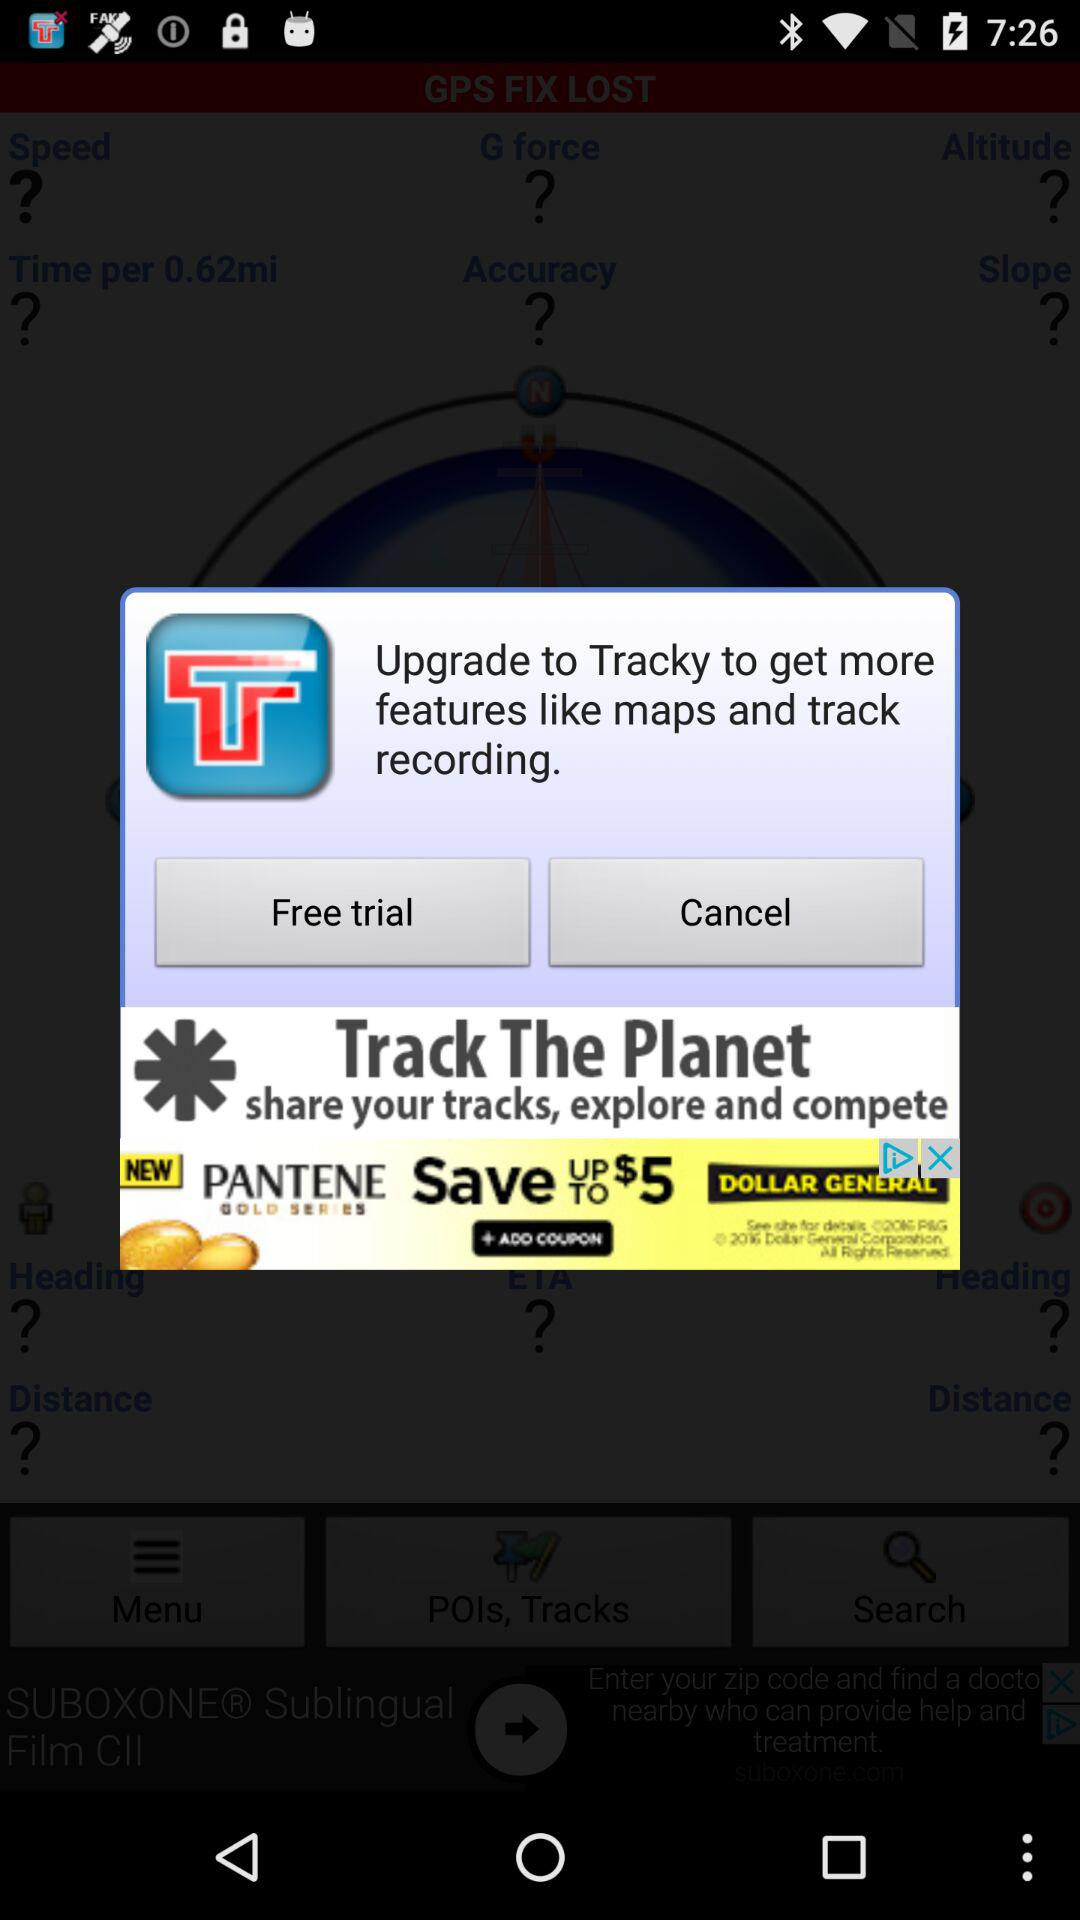How many features are mentioned in the upgrade prompt?
Answer the question using a single word or phrase. 2 